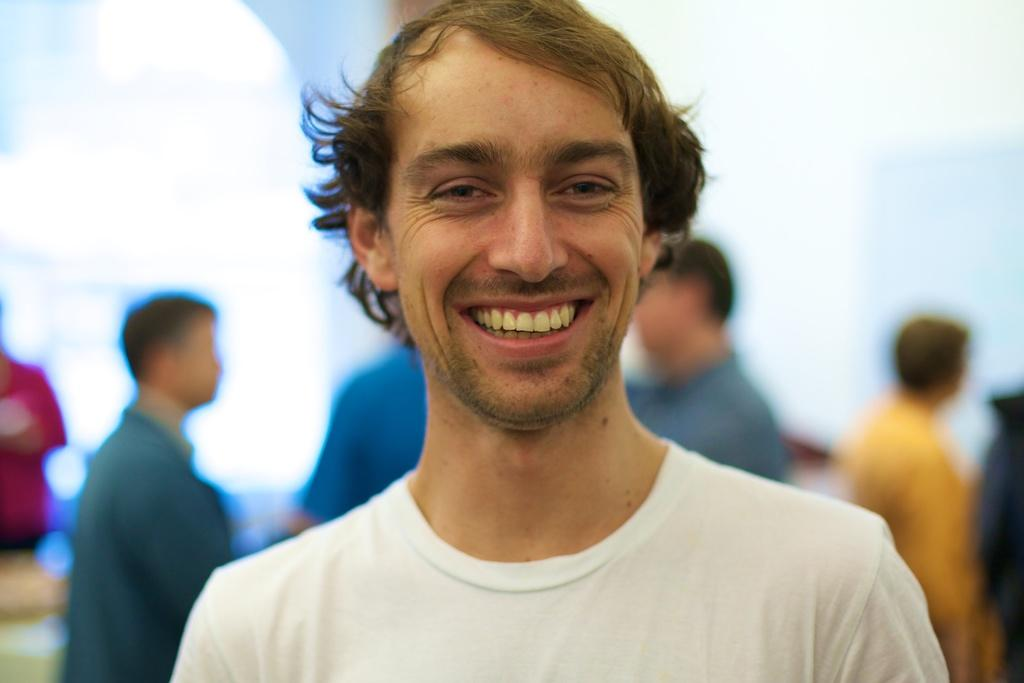Who is present in the image? There is a person in the image. What is the person doing in the image? The person is smiling. What is the person wearing in the image? The person is wearing a white T-shirt. Are there any other people visible in the image? Yes, there are other persons standing in the background of the image. What type of worm can be seen crawling on the person's shirt in the image? There is no worm present on the person's shirt in the image. 